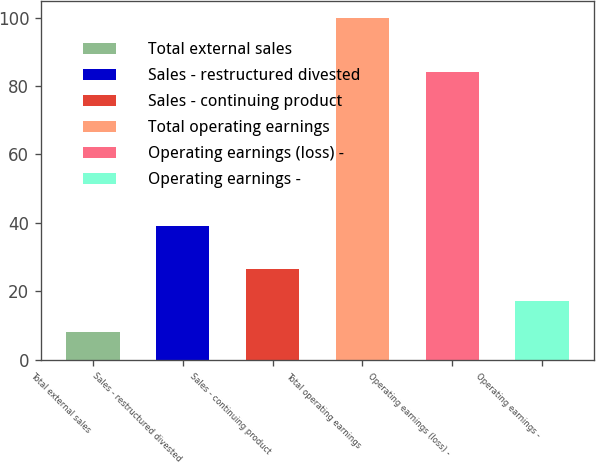Convert chart to OTSL. <chart><loc_0><loc_0><loc_500><loc_500><bar_chart><fcel>Total external sales<fcel>Sales - restructured divested<fcel>Sales - continuing product<fcel>Total operating earnings<fcel>Operating earnings (loss) -<fcel>Operating earnings -<nl><fcel>8<fcel>39<fcel>26.4<fcel>100<fcel>84<fcel>17.2<nl></chart> 